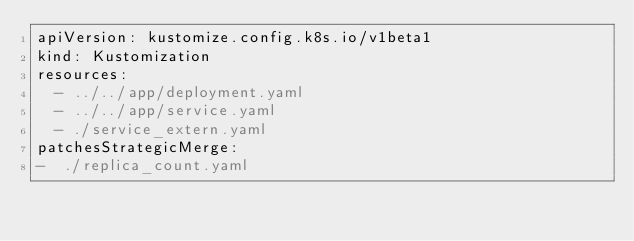<code> <loc_0><loc_0><loc_500><loc_500><_YAML_>apiVersion: kustomize.config.k8s.io/v1beta1
kind: Kustomization
resources:
  - ../../app/deployment.yaml
  - ../../app/service.yaml
  - ./service_extern.yaml
patchesStrategicMerge:
-  ./replica_count.yaml
  </code> 